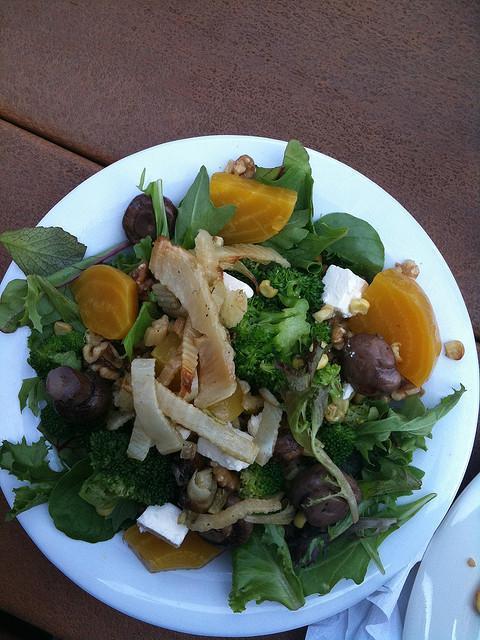How many broccolis are in the picture?
Give a very brief answer. 2. How many people are on the beach?
Give a very brief answer. 0. 